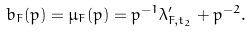<formula> <loc_0><loc_0><loc_500><loc_500>b _ { F } ( p ) = \mu _ { F } ( p ) = p ^ { - 1 } \lambda ^ { \prime } _ { F , t _ { 2 } } + p ^ { - 2 } .</formula> 